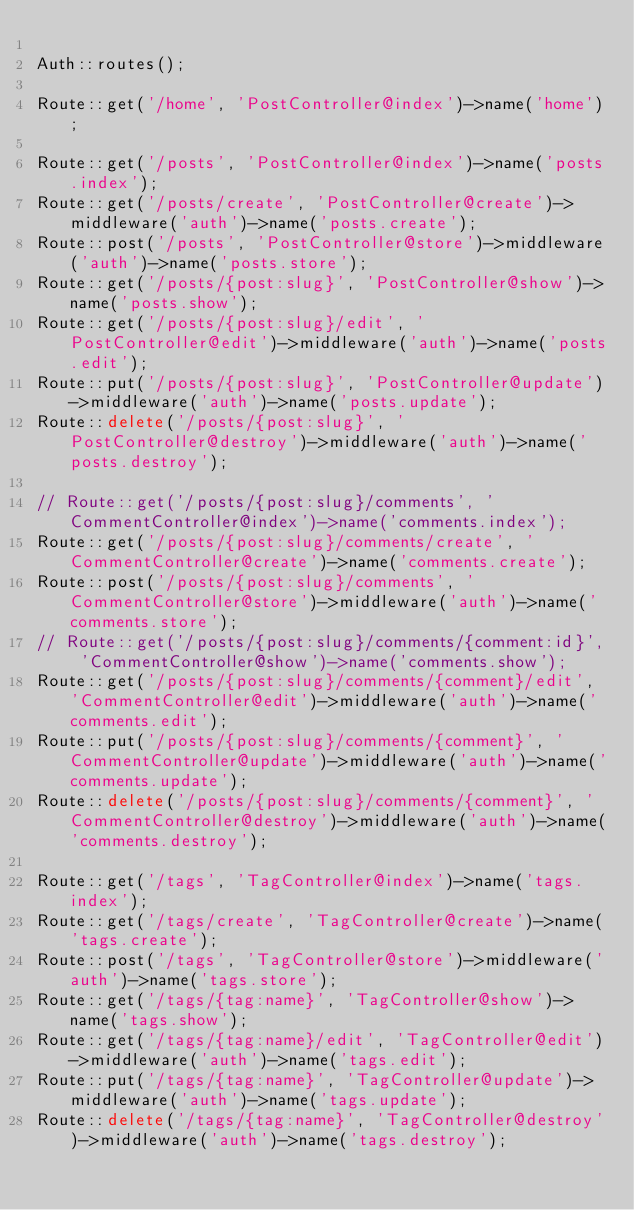<code> <loc_0><loc_0><loc_500><loc_500><_PHP_>
Auth::routes();

Route::get('/home', 'PostController@index')->name('home');

Route::get('/posts', 'PostController@index')->name('posts.index');
Route::get('/posts/create', 'PostController@create')->middleware('auth')->name('posts.create');
Route::post('/posts', 'PostController@store')->middleware('auth')->name('posts.store');
Route::get('/posts/{post:slug}', 'PostController@show')->name('posts.show');
Route::get('/posts/{post:slug}/edit', 'PostController@edit')->middleware('auth')->name('posts.edit');
Route::put('/posts/{post:slug}', 'PostController@update')->middleware('auth')->name('posts.update');
Route::delete('/posts/{post:slug}', 'PostController@destroy')->middleware('auth')->name('posts.destroy');

// Route::get('/posts/{post:slug}/comments', 'CommentController@index')->name('comments.index');
Route::get('/posts/{post:slug}/comments/create', 'CommentController@create')->name('comments.create');
Route::post('/posts/{post:slug}/comments', 'CommentController@store')->middleware('auth')->name('comments.store');
// Route::get('/posts/{post:slug}/comments/{comment:id}', 'CommentController@show')->name('comments.show');
Route::get('/posts/{post:slug}/comments/{comment}/edit', 'CommentController@edit')->middleware('auth')->name('comments.edit');
Route::put('/posts/{post:slug}/comments/{comment}', 'CommentController@update')->middleware('auth')->name('comments.update');
Route::delete('/posts/{post:slug}/comments/{comment}', 'CommentController@destroy')->middleware('auth')->name('comments.destroy');

Route::get('/tags', 'TagController@index')->name('tags.index');
Route::get('/tags/create', 'TagController@create')->name('tags.create');
Route::post('/tags', 'TagController@store')->middleware('auth')->name('tags.store');
Route::get('/tags/{tag:name}', 'TagController@show')->name('tags.show');
Route::get('/tags/{tag:name}/edit', 'TagController@edit')->middleware('auth')->name('tags.edit');
Route::put('/tags/{tag:name}', 'TagController@update')->middleware('auth')->name('tags.update');
Route::delete('/tags/{tag:name}', 'TagController@destroy')->middleware('auth')->name('tags.destroy');
</code> 